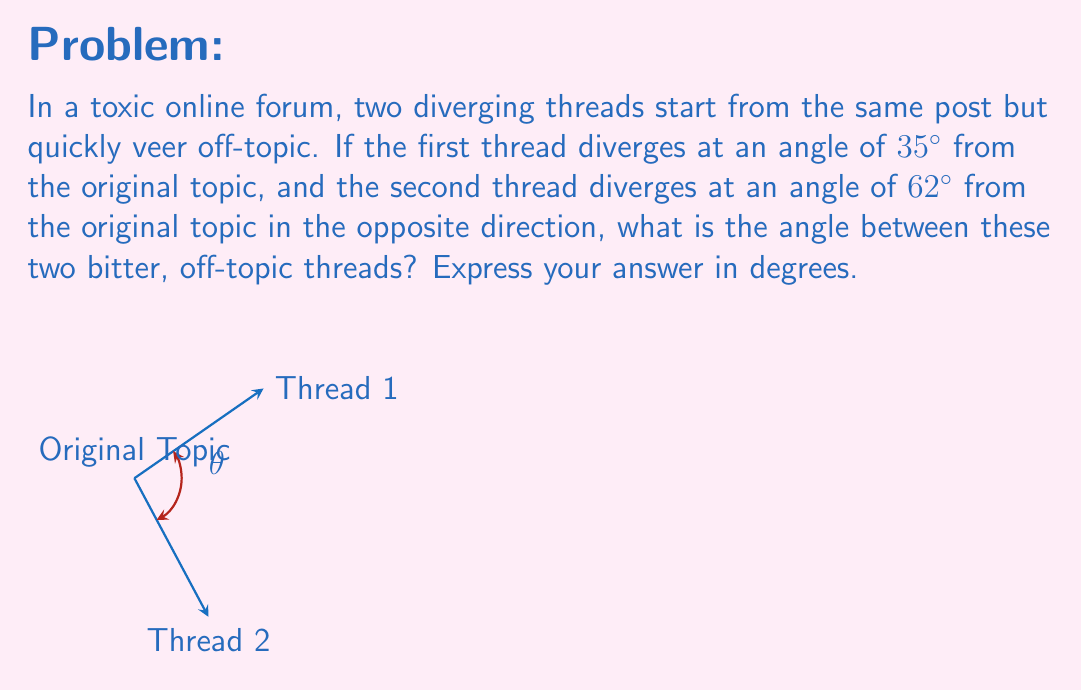Help me with this question. To solve this problem, we need to understand that the angle between the two threads is the sum of their individual angles from the original topic. Let's break it down step-by-step:

1) The first thread diverges at an angle of $35^\circ$ from the original topic.

2) The second thread diverges at an angle of $62^\circ$ from the original topic, but in the opposite direction. This means it's actually $-62^\circ$ relative to the first thread.

3) To find the total angle between the threads, we need to add the absolute values of these angles:

   $$\theta = |35^\circ| + |-62^\circ| = 35^\circ + 62^\circ = 97^\circ$$

4) The absolute value is used because we're interested in the magnitude of the angle, not its direction.

This calculation gives us the angle between the two diverging threads, representing how far apart these bitter, off-topic discussions have become from each other in the geometric space of the forum.
Answer: $97^\circ$ 